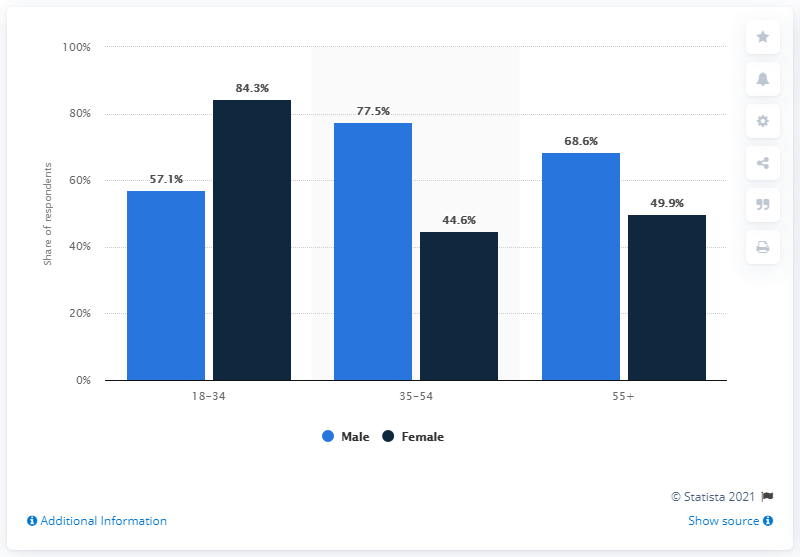Give some essential details in this illustration. The smallest value in the 18-34 category is 57.1. The average of all blue bars in the chart is 67.73. 